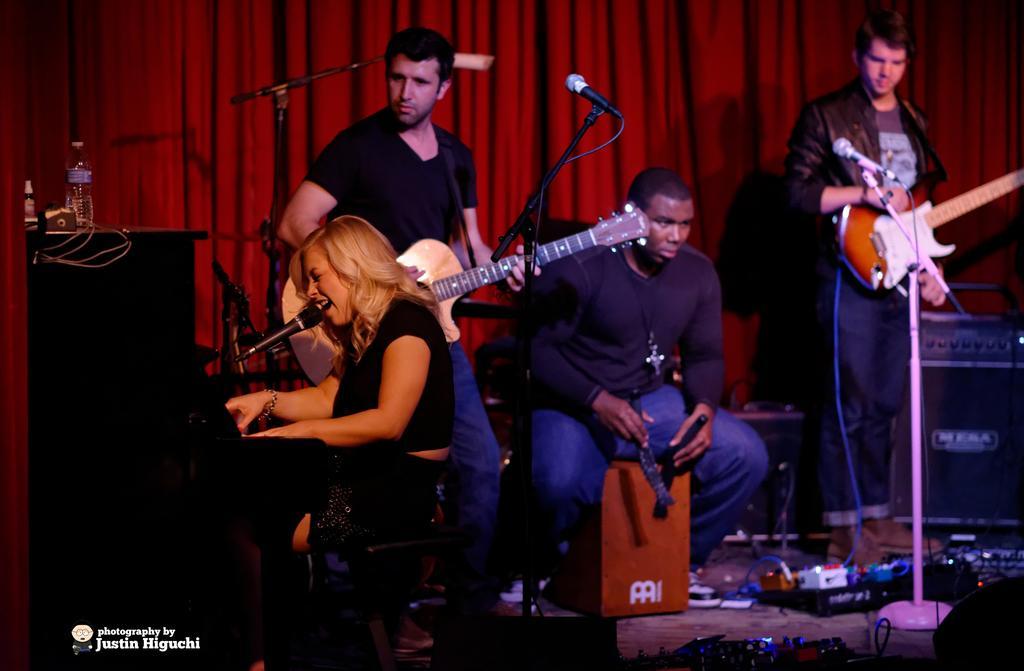Describe this image in one or two sentences. In this picture there are four people holding some musical instruments and there are some speakers and a desk on which some things are placed and there is a red cotton behind them. 